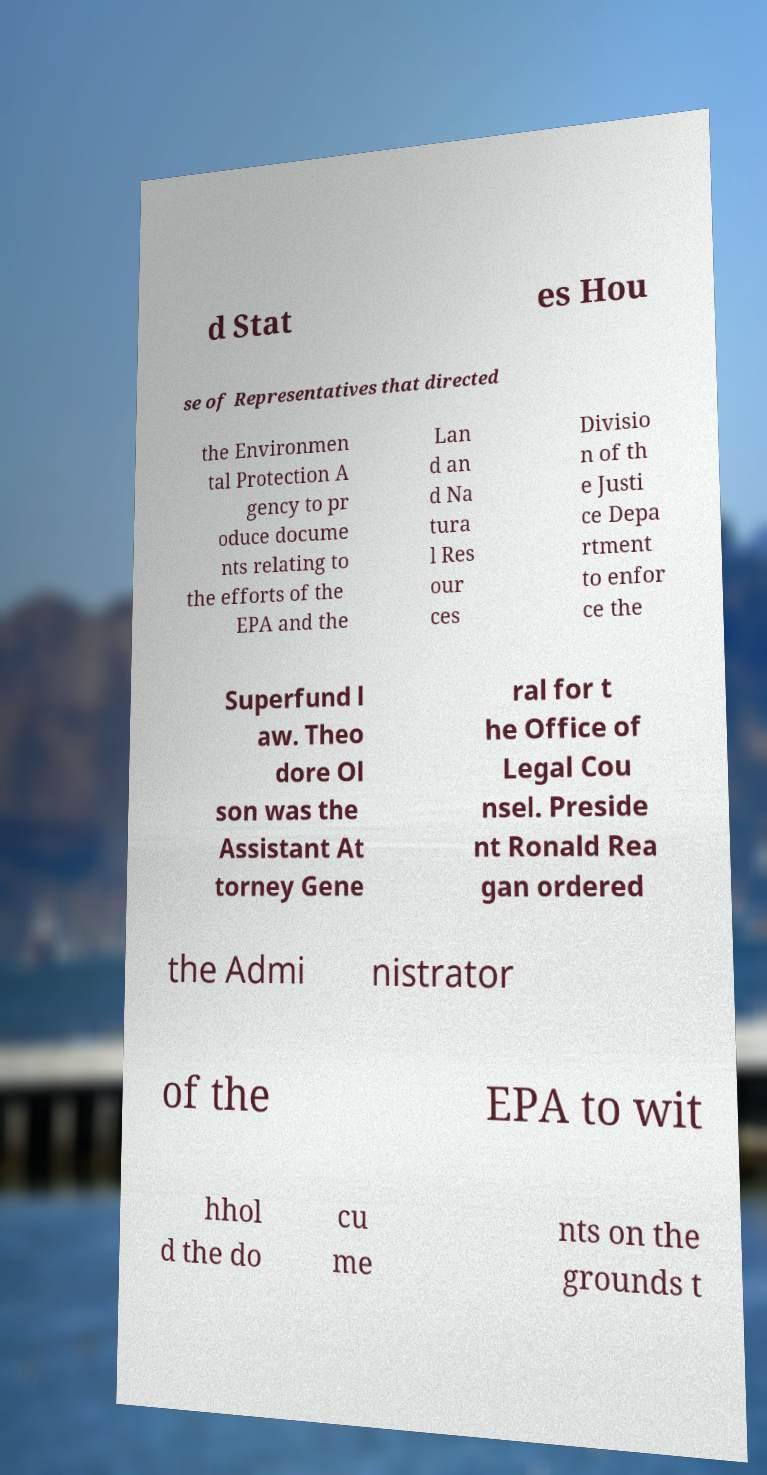Could you extract and type out the text from this image? d Stat es Hou se of Representatives that directed the Environmen tal Protection A gency to pr oduce docume nts relating to the efforts of the EPA and the Lan d an d Na tura l Res our ces Divisio n of th e Justi ce Depa rtment to enfor ce the Superfund l aw. Theo dore Ol son was the Assistant At torney Gene ral for t he Office of Legal Cou nsel. Preside nt Ronald Rea gan ordered the Admi nistrator of the EPA to wit hhol d the do cu me nts on the grounds t 